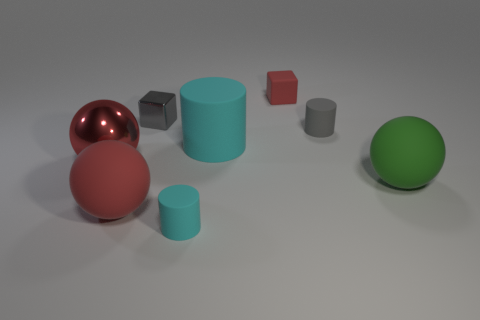Subtract all cyan cylinders. How many red spheres are left? 2 Subtract all small rubber cylinders. How many cylinders are left? 1 Add 2 red metallic spheres. How many objects exist? 10 Subtract all gray spheres. Subtract all yellow cylinders. How many spheres are left? 3 Subtract all cylinders. How many objects are left? 5 Add 1 tiny cyan matte things. How many tiny cyan matte things exist? 2 Subtract 1 red cubes. How many objects are left? 7 Subtract all tiny yellow objects. Subtract all big green balls. How many objects are left? 7 Add 7 large rubber cylinders. How many large rubber cylinders are left? 8 